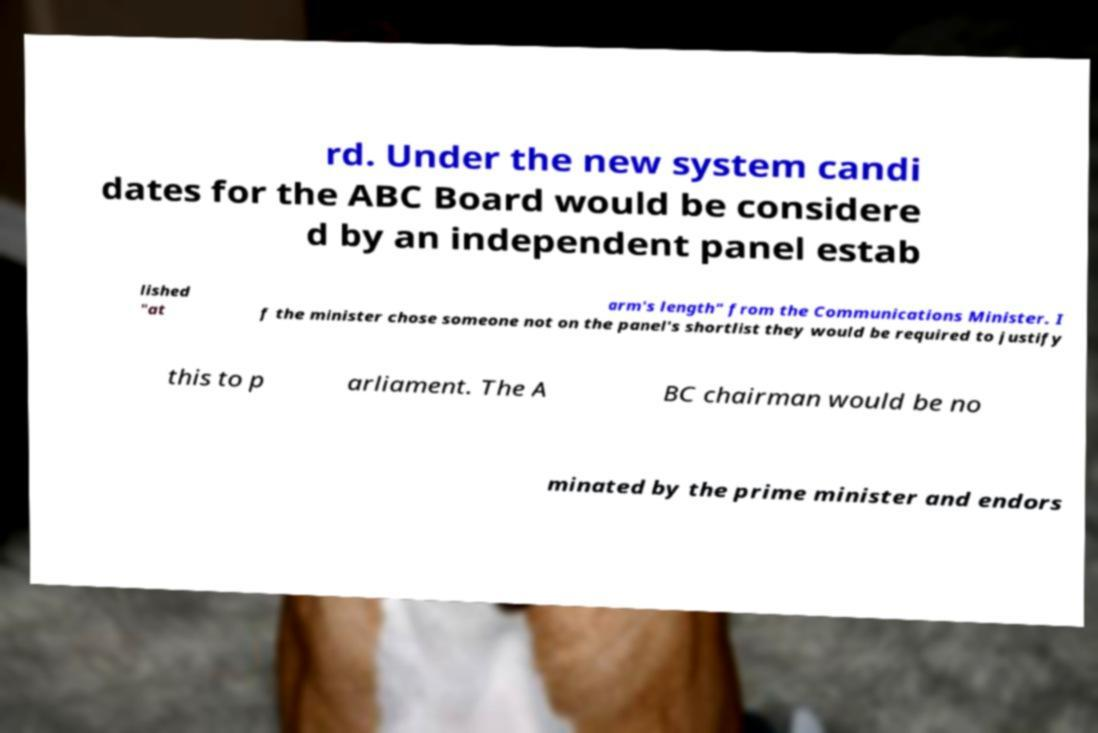Could you extract and type out the text from this image? rd. Under the new system candi dates for the ABC Board would be considere d by an independent panel estab lished "at arm's length" from the Communications Minister. I f the minister chose someone not on the panel's shortlist they would be required to justify this to p arliament. The A BC chairman would be no minated by the prime minister and endors 